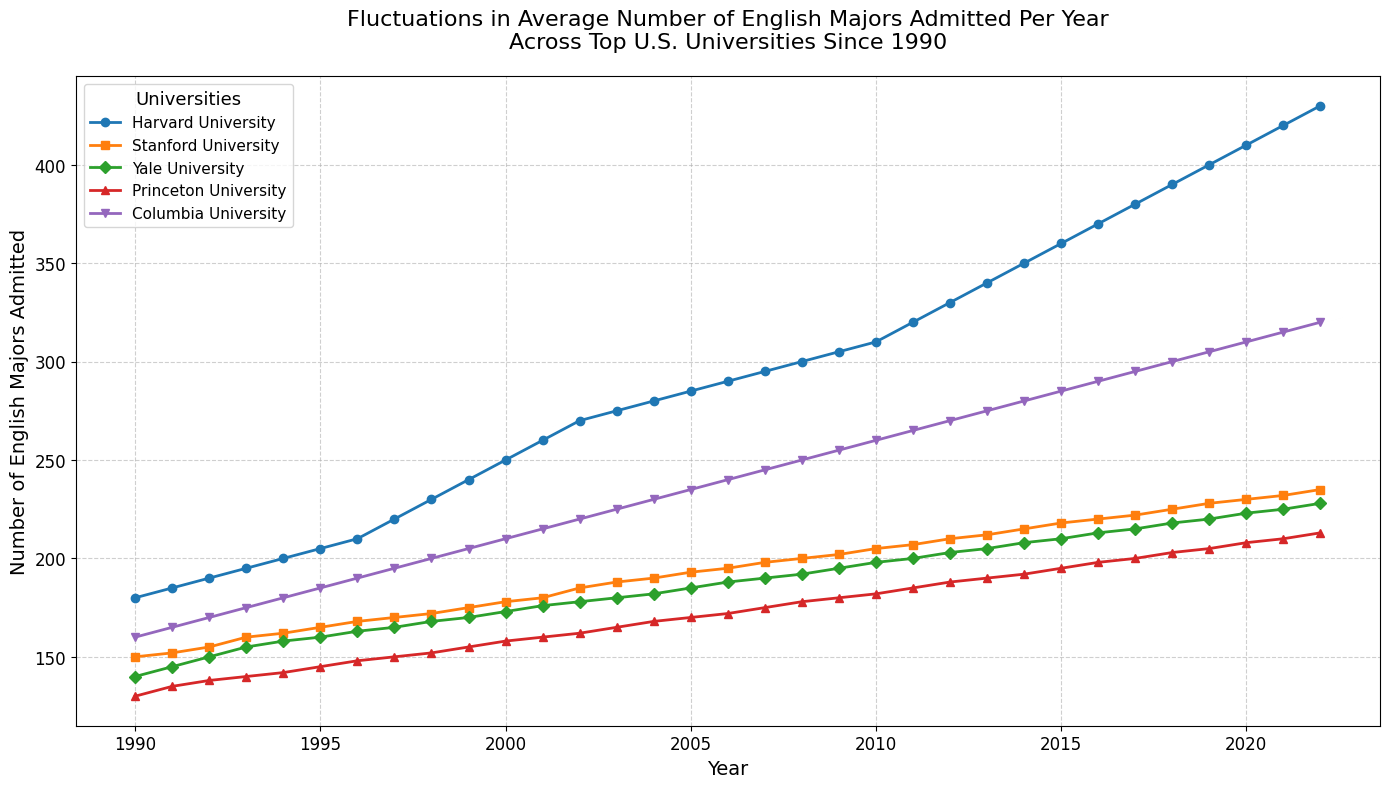what is the highest number of admissions in the latest year available across all universities? Check the data points for the year 2022 for each university. The highest number is 430 for Harvard University.
Answer: 430 By how much did the number of English majors admitted to Yale University increase from 1991 to 2005 as compared to Stanford University in the same period? Calculate the differences separately and then find the discrepancy between them.
For Yale (1991 to 2005):
- 185 - 145 = 40
For Stanford (1991 to 2005):
- 193 - 152 = 41
The difference is 41 - 40 = 1. Stanford had one more increase in admitted students compared to Yale.
Answer: 1 What is the average number of English majors admitted per year for Columbia University from 1990 to 2022? Sum the numbers for each year from 1990 to 2022, then divide by the total number of years (33).
Sum = 160 + 165 + 170 + ... + 315 + 320 = 7285
Average = 7285 / 33 ≈ 220.76
Answer: 220.76 In which year did Stanford University start admitting more than 200 English majors per year? Locate the first year in which numbers for Stanford crossed the 200 mark.
The year is 2009 when Stanford admitted 202 majors.
Answer: 2009 